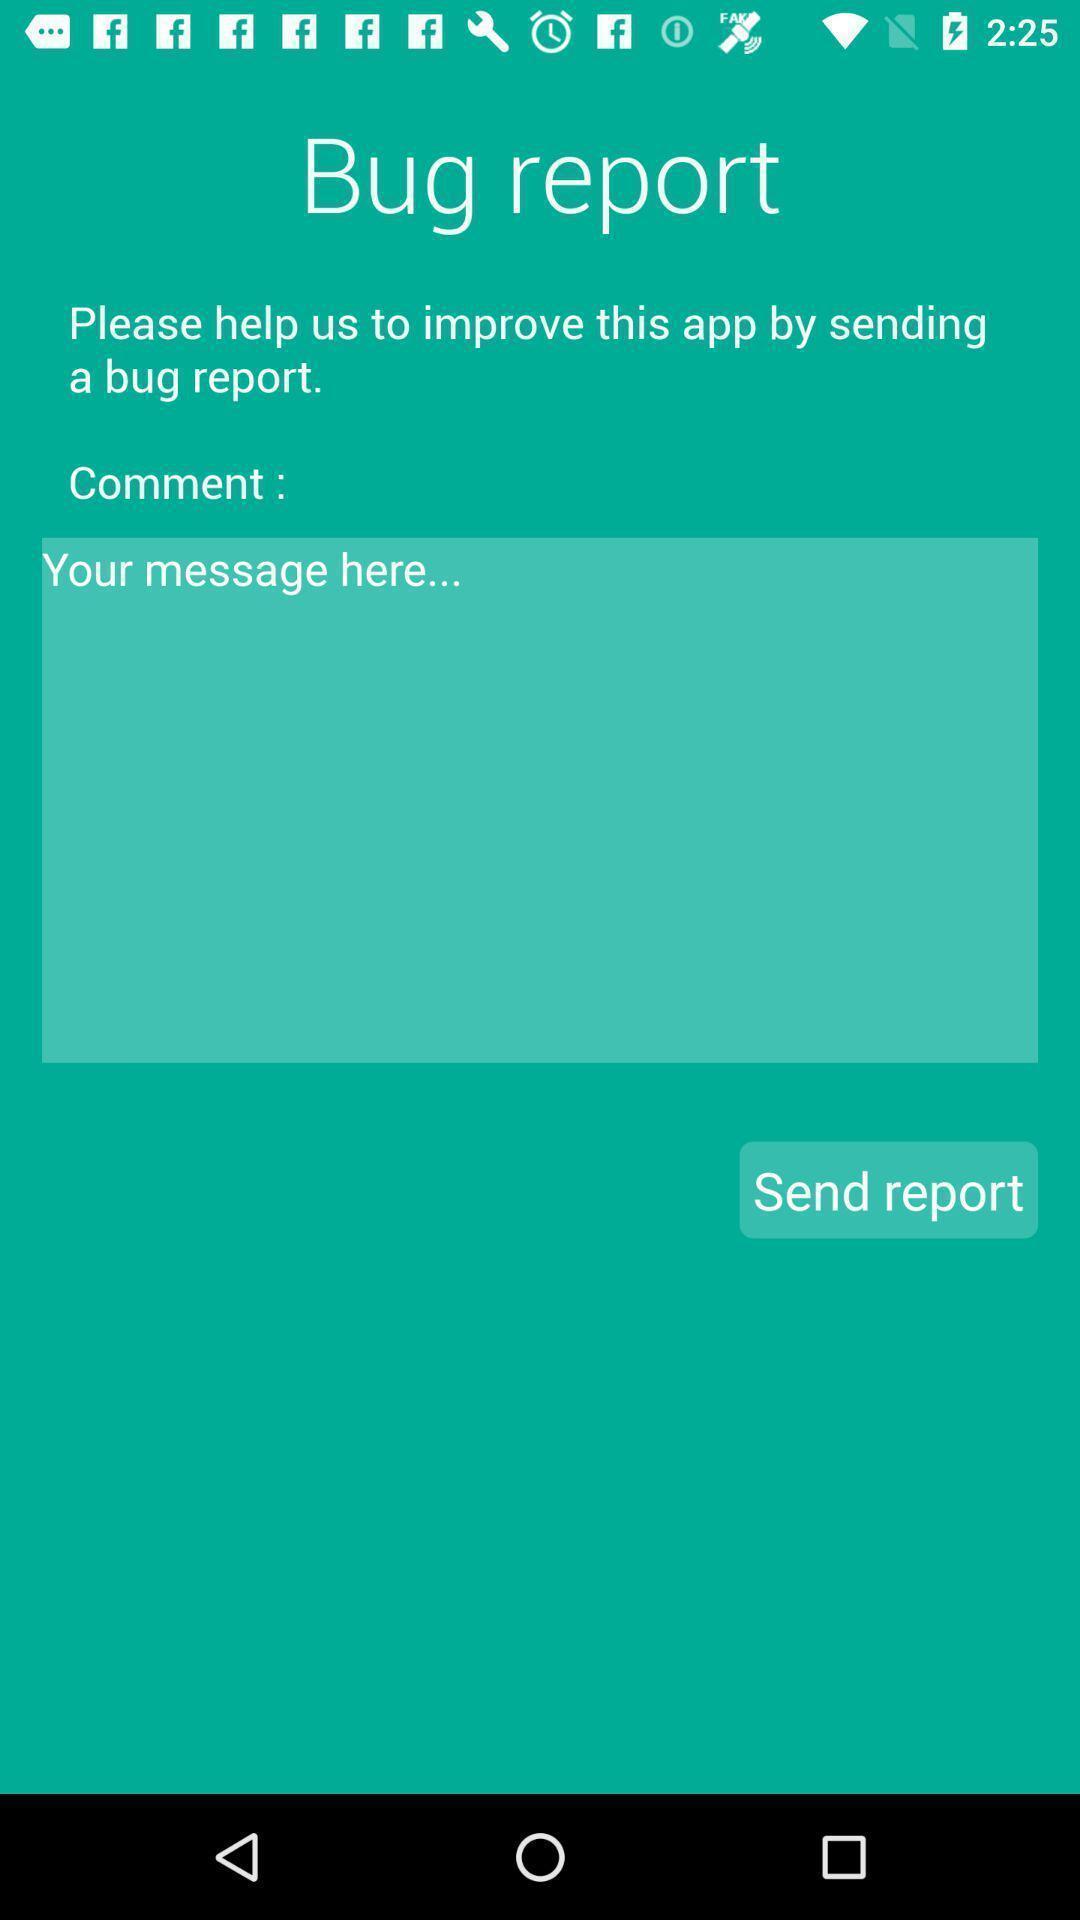Please provide a description for this image. Page requesting to issue bug reports on an app. 